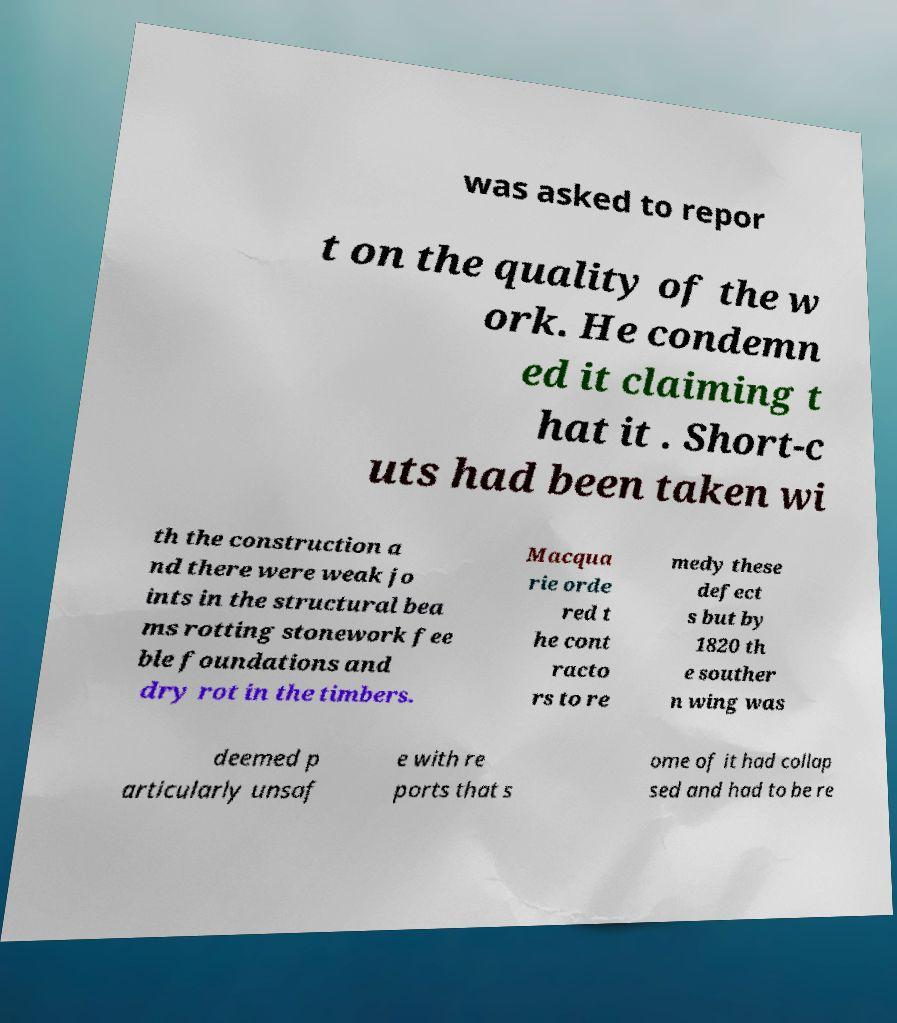Can you read and provide the text displayed in the image?This photo seems to have some interesting text. Can you extract and type it out for me? was asked to repor t on the quality of the w ork. He condemn ed it claiming t hat it . Short-c uts had been taken wi th the construction a nd there were weak jo ints in the structural bea ms rotting stonework fee ble foundations and dry rot in the timbers. Macqua rie orde red t he cont racto rs to re medy these defect s but by 1820 th e souther n wing was deemed p articularly unsaf e with re ports that s ome of it had collap sed and had to be re 